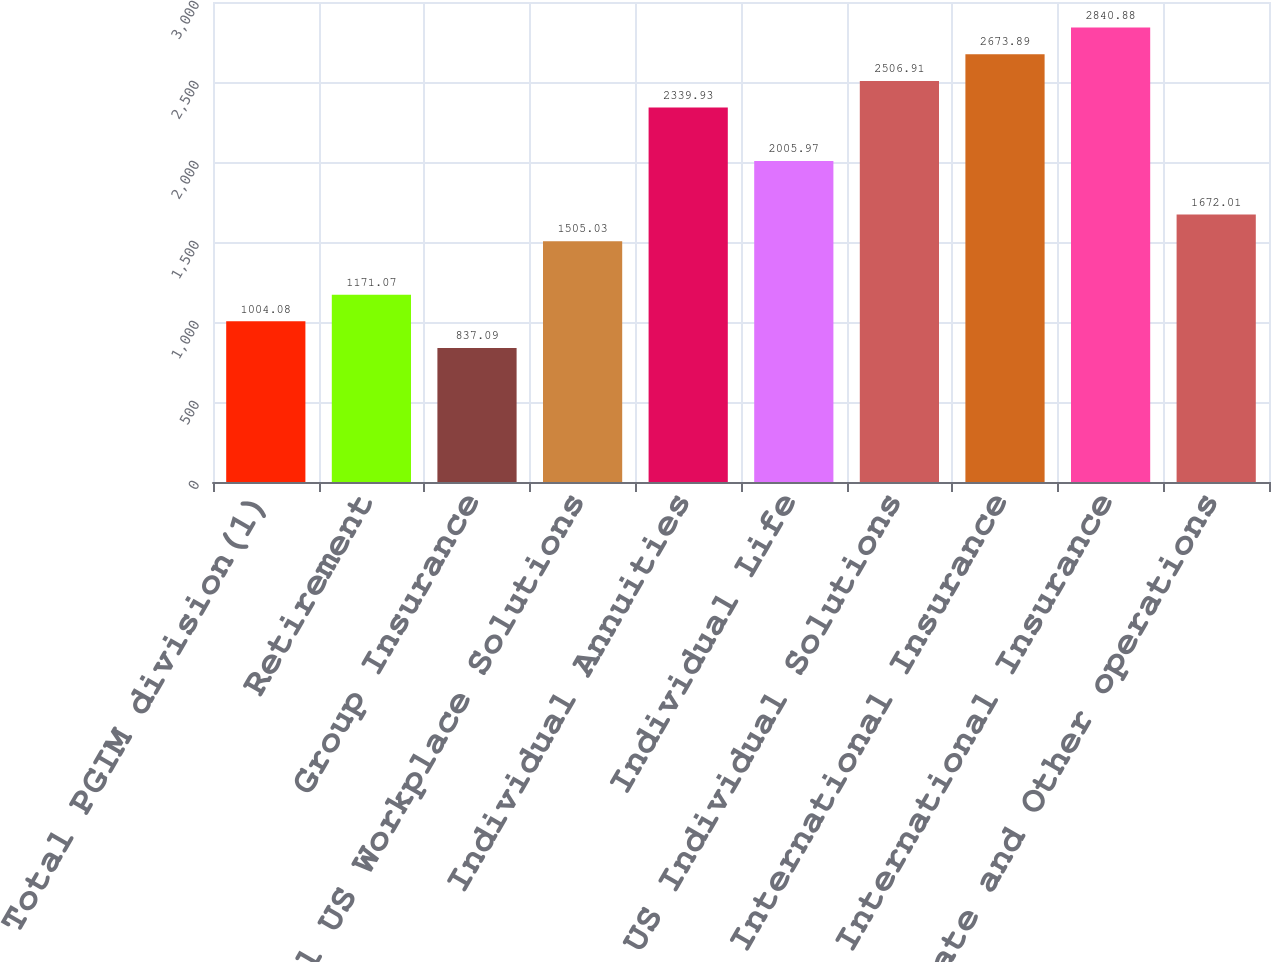<chart> <loc_0><loc_0><loc_500><loc_500><bar_chart><fcel>Total PGIM division(1)<fcel>Retirement<fcel>Group Insurance<fcel>Total US Workplace Solutions<fcel>Individual Annuities<fcel>Individual Life<fcel>Total US Individual Solutions<fcel>International Insurance<fcel>Total International Insurance<fcel>Corporate and Other operations<nl><fcel>1004.08<fcel>1171.07<fcel>837.09<fcel>1505.03<fcel>2339.93<fcel>2005.97<fcel>2506.91<fcel>2673.89<fcel>2840.88<fcel>1672.01<nl></chart> 